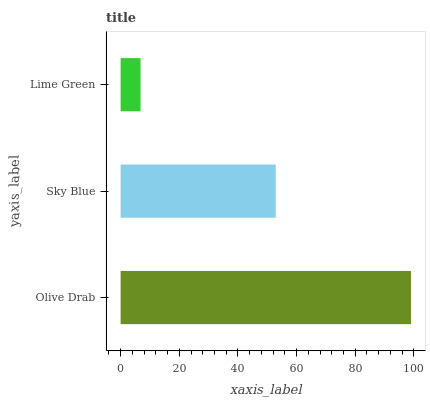Is Lime Green the minimum?
Answer yes or no. Yes. Is Olive Drab the maximum?
Answer yes or no. Yes. Is Sky Blue the minimum?
Answer yes or no. No. Is Sky Blue the maximum?
Answer yes or no. No. Is Olive Drab greater than Sky Blue?
Answer yes or no. Yes. Is Sky Blue less than Olive Drab?
Answer yes or no. Yes. Is Sky Blue greater than Olive Drab?
Answer yes or no. No. Is Olive Drab less than Sky Blue?
Answer yes or no. No. Is Sky Blue the high median?
Answer yes or no. Yes. Is Sky Blue the low median?
Answer yes or no. Yes. Is Lime Green the high median?
Answer yes or no. No. Is Olive Drab the low median?
Answer yes or no. No. 